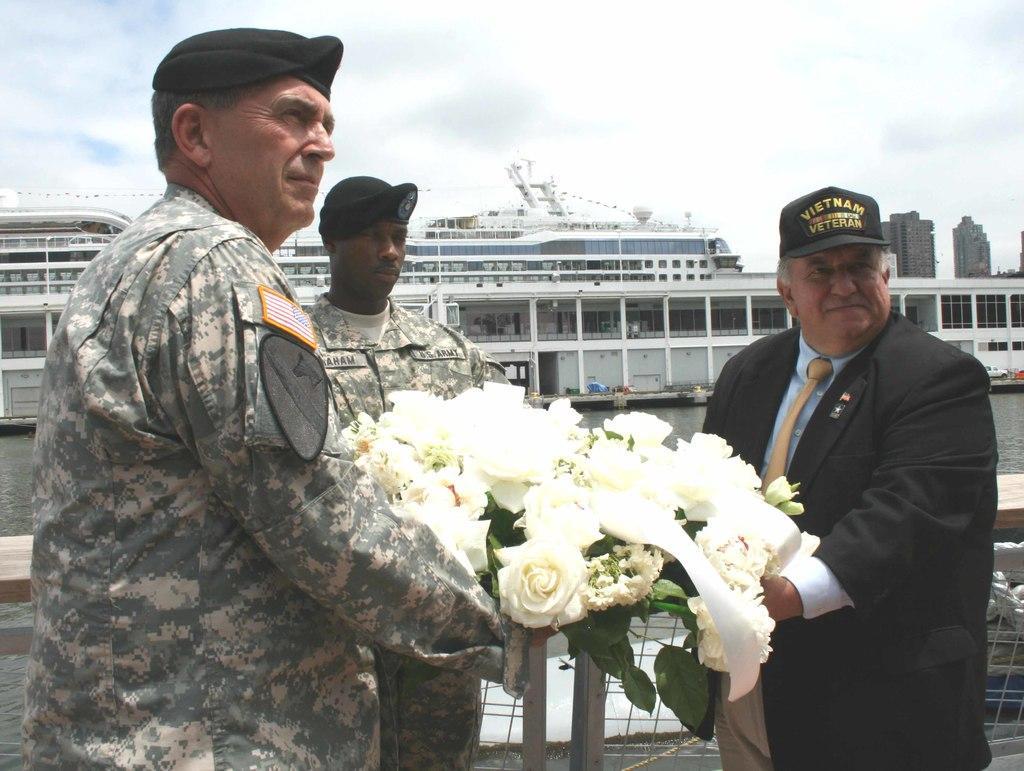Can you describe this image briefly? In this image there is a man in black dress is giving flowers to the officer behind him there is another man standing, at the back there is a big ship in the water. 